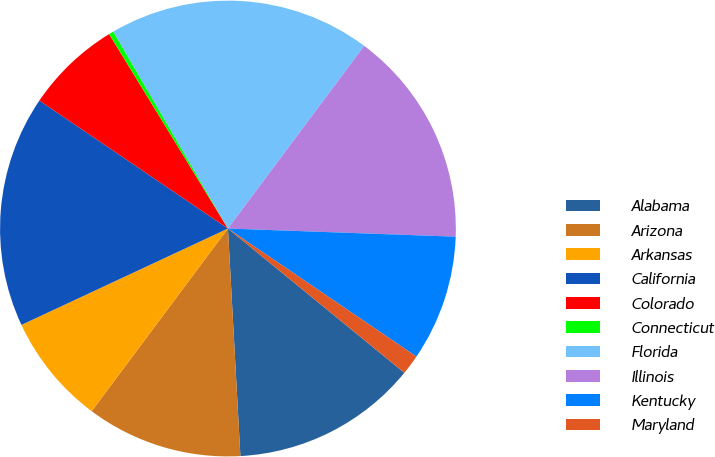Convert chart to OTSL. <chart><loc_0><loc_0><loc_500><loc_500><pie_chart><fcel>Alabama<fcel>Arizona<fcel>Arkansas<fcel>California<fcel>Colorado<fcel>Connecticut<fcel>Florida<fcel>Illinois<fcel>Kentucky<fcel>Maryland<nl><fcel>13.22%<fcel>11.07%<fcel>7.85%<fcel>16.44%<fcel>6.78%<fcel>0.34%<fcel>18.59%<fcel>15.37%<fcel>8.93%<fcel>1.41%<nl></chart> 